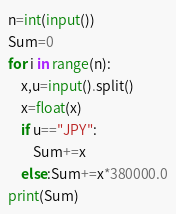Convert code to text. <code><loc_0><loc_0><loc_500><loc_500><_Python_>n=int(input())
Sum=0
for i in range(n):
    x,u=input().split()
    x=float(x)
    if u=="JPY":
        Sum+=x
    else:Sum+=x*380000.0
print(Sum)</code> 